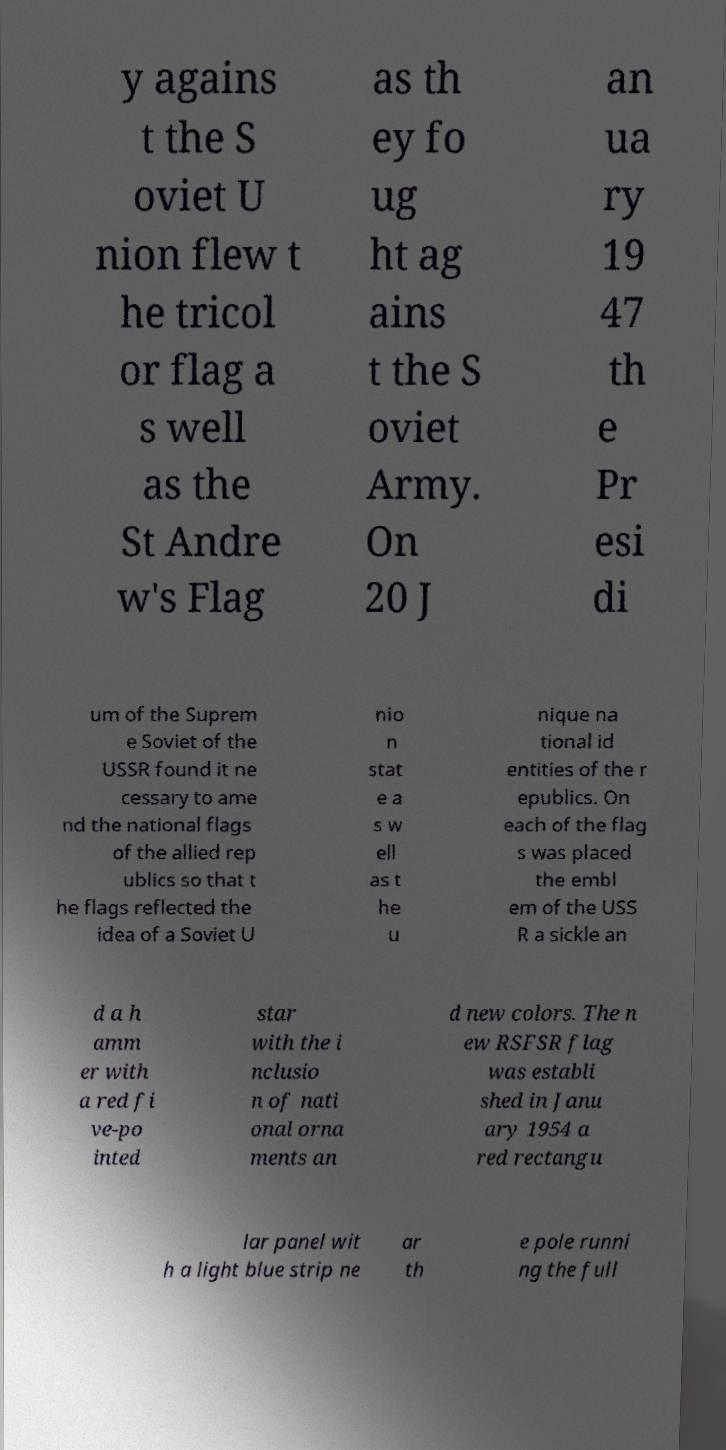Can you read and provide the text displayed in the image?This photo seems to have some interesting text. Can you extract and type it out for me? y agains t the S oviet U nion flew t he tricol or flag a s well as the St Andre w's Flag as th ey fo ug ht ag ains t the S oviet Army. On 20 J an ua ry 19 47 th e Pr esi di um of the Suprem e Soviet of the USSR found it ne cessary to ame nd the national flags of the allied rep ublics so that t he flags reflected the idea of a Soviet U nio n stat e a s w ell as t he u nique na tional id entities of the r epublics. On each of the flag s was placed the embl em of the USS R a sickle an d a h amm er with a red fi ve-po inted star with the i nclusio n of nati onal orna ments an d new colors. The n ew RSFSR flag was establi shed in Janu ary 1954 a red rectangu lar panel wit h a light blue strip ne ar th e pole runni ng the full 